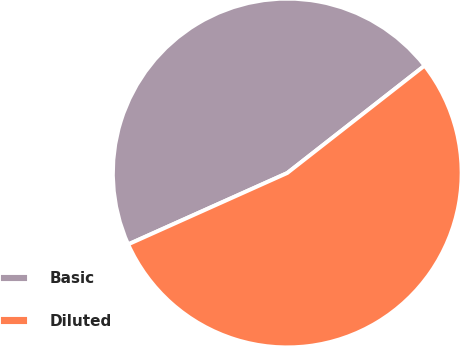Convert chart to OTSL. <chart><loc_0><loc_0><loc_500><loc_500><pie_chart><fcel>Basic<fcel>Diluted<nl><fcel>46.15%<fcel>53.85%<nl></chart> 